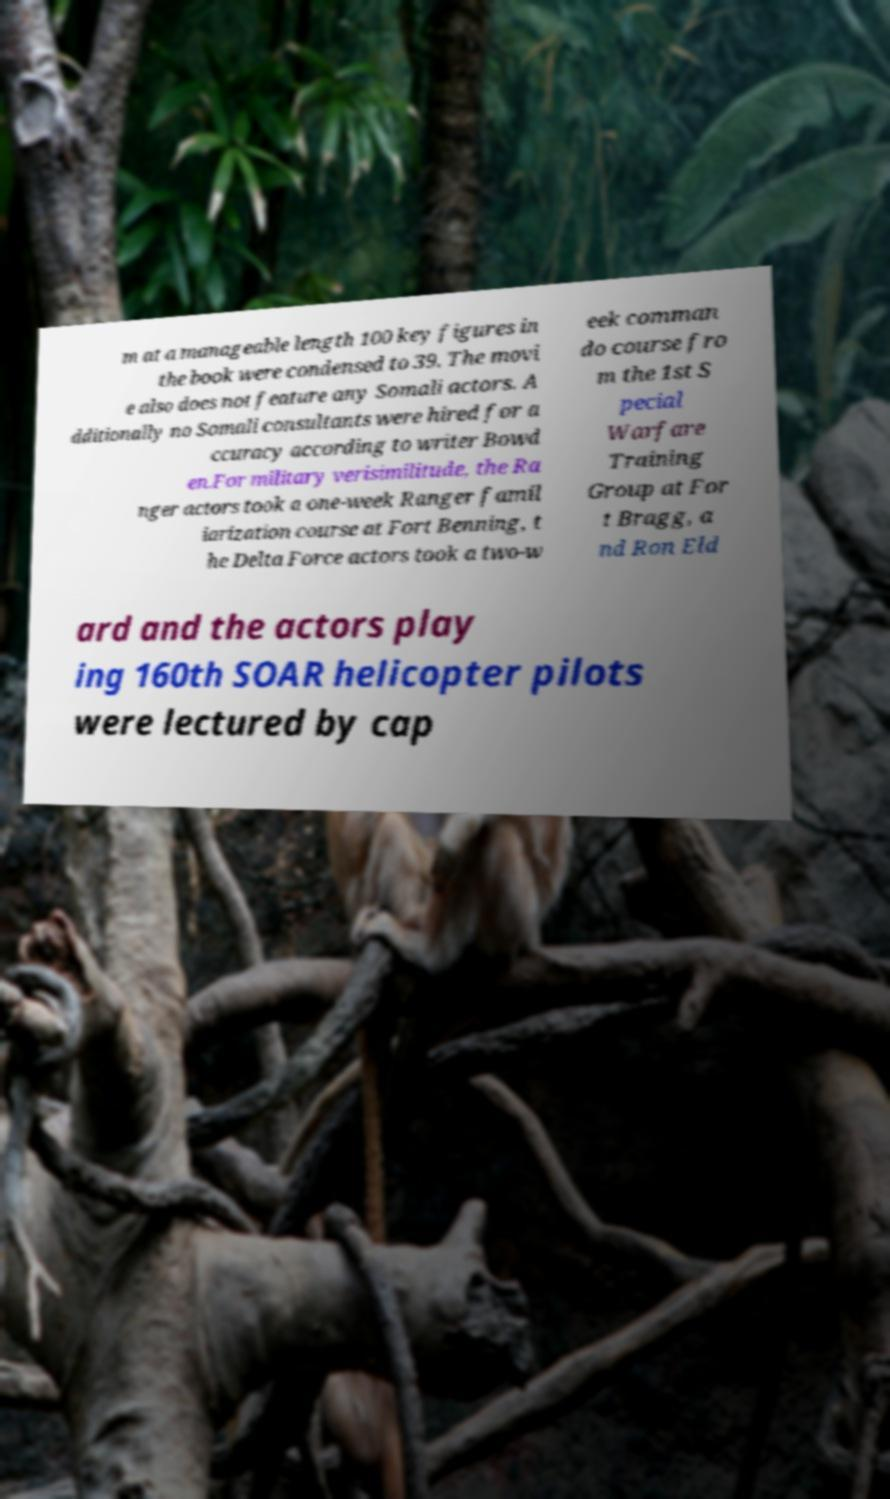Could you extract and type out the text from this image? m at a manageable length 100 key figures in the book were condensed to 39. The movi e also does not feature any Somali actors. A dditionally no Somali consultants were hired for a ccuracy according to writer Bowd en.For military verisimilitude, the Ra nger actors took a one-week Ranger famil iarization course at Fort Benning, t he Delta Force actors took a two-w eek comman do course fro m the 1st S pecial Warfare Training Group at For t Bragg, a nd Ron Eld ard and the actors play ing 160th SOAR helicopter pilots were lectured by cap 